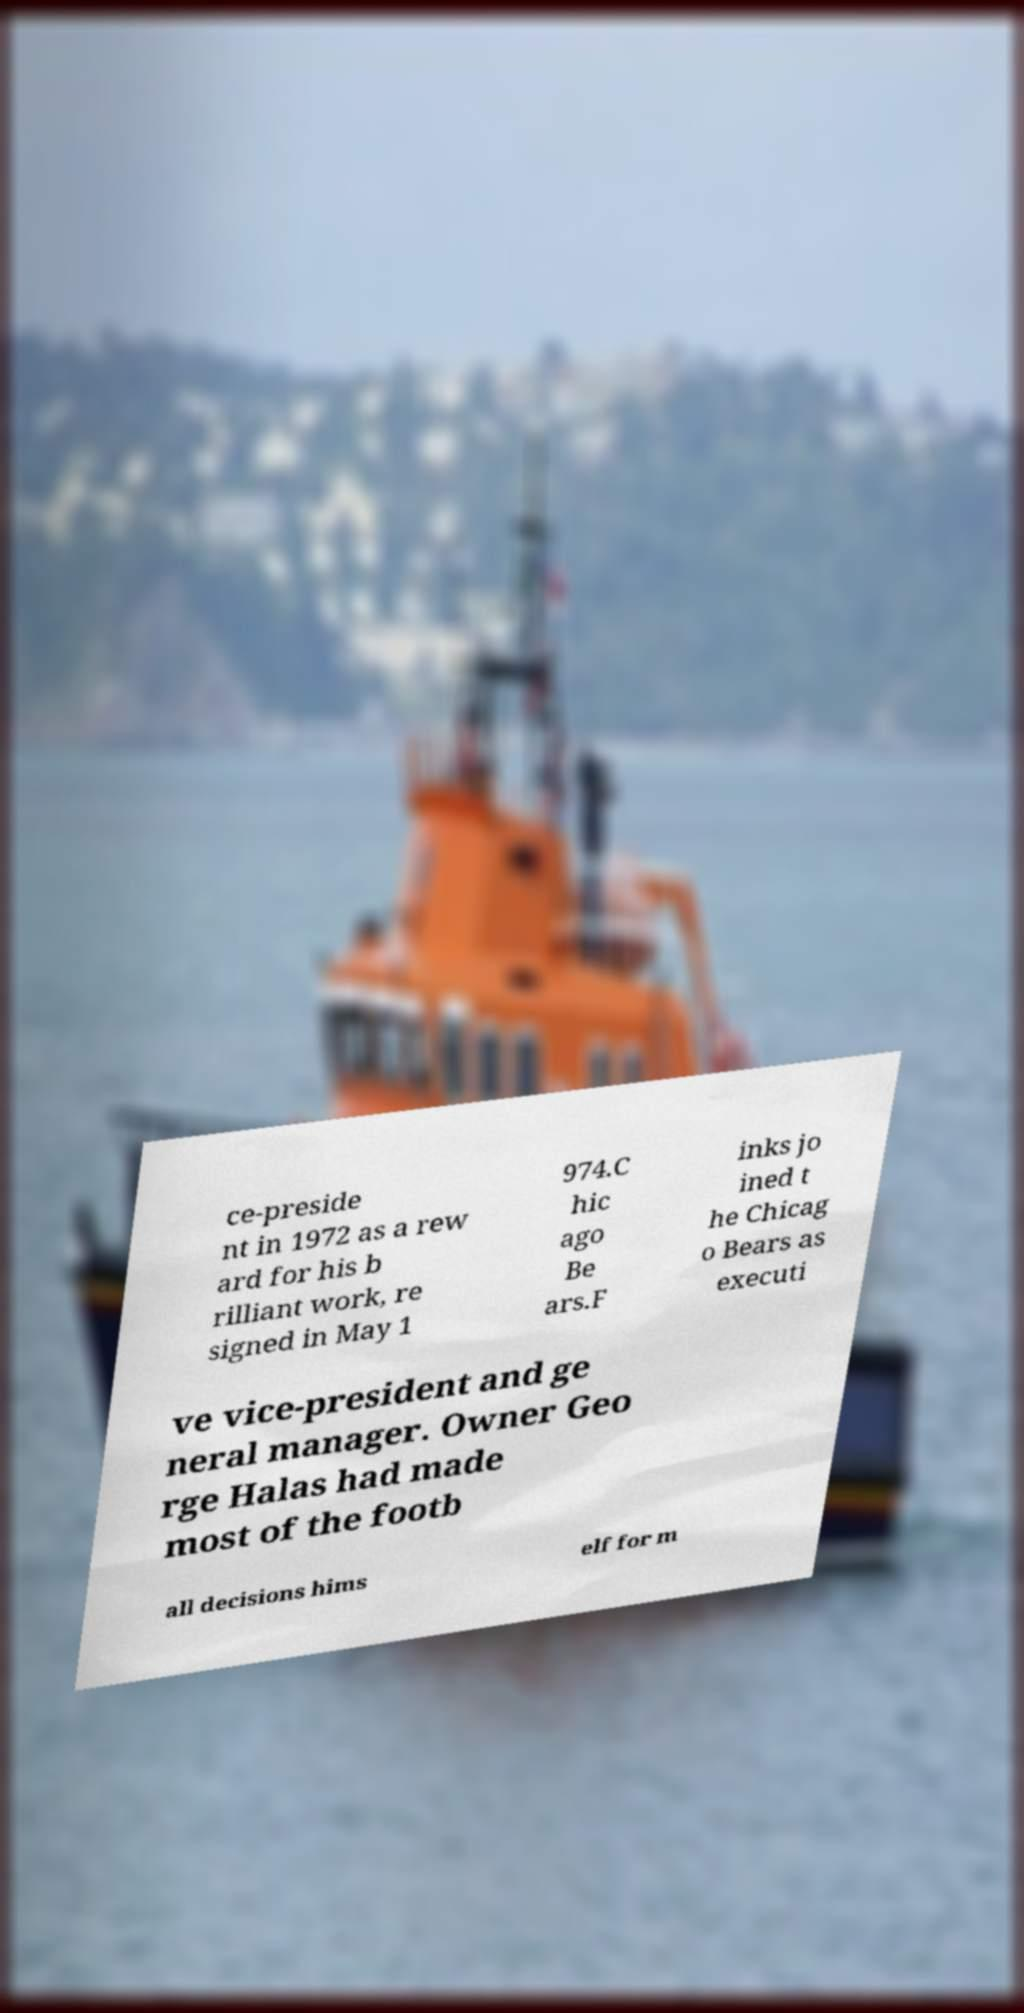Can you accurately transcribe the text from the provided image for me? ce-preside nt in 1972 as a rew ard for his b rilliant work, re signed in May 1 974.C hic ago Be ars.F inks jo ined t he Chicag o Bears as executi ve vice-president and ge neral manager. Owner Geo rge Halas had made most of the footb all decisions hims elf for m 